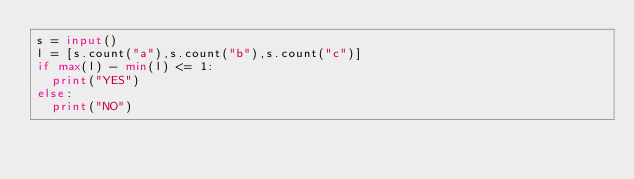<code> <loc_0><loc_0><loc_500><loc_500><_Python_>s = input()
l = [s.count("a"),s.count("b"),s.count("c")]
if max(l) - min(l) <= 1:
  print("YES")
else:
  print("NO")
  
</code> 